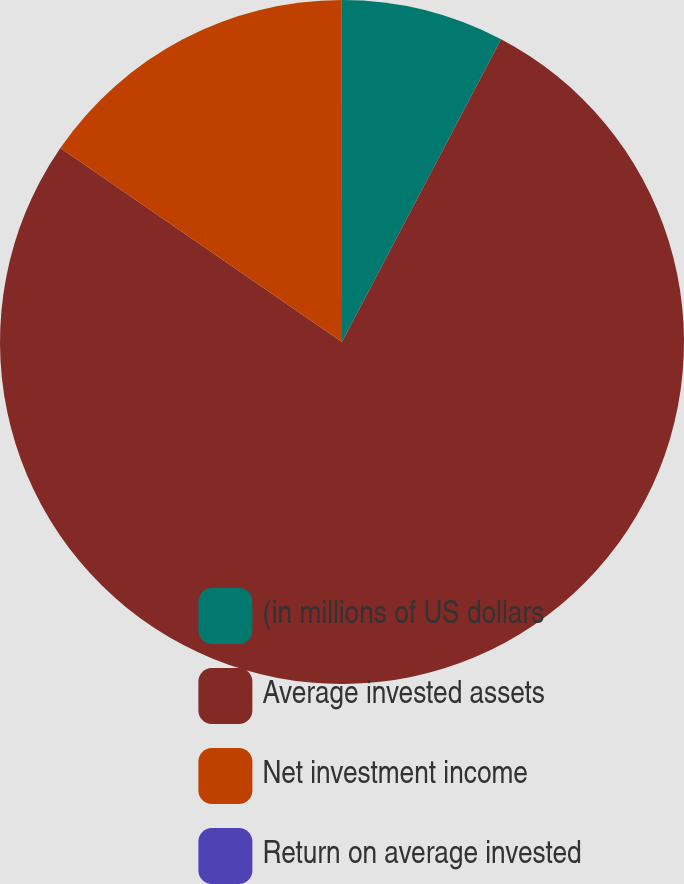Convert chart to OTSL. <chart><loc_0><loc_0><loc_500><loc_500><pie_chart><fcel>(in millions of US dollars<fcel>Average invested assets<fcel>Net investment income<fcel>Return on average invested<nl><fcel>7.7%<fcel>76.91%<fcel>15.39%<fcel>0.01%<nl></chart> 